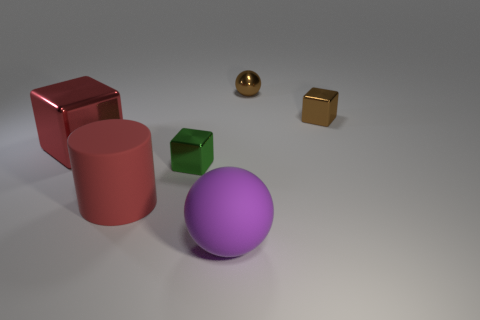Could this image be a representation of something metaphorical? It's possible; the arrangement of mundane objects with varying shapes and colors could metaphorically represent diversity or uniqueness among commonality. 